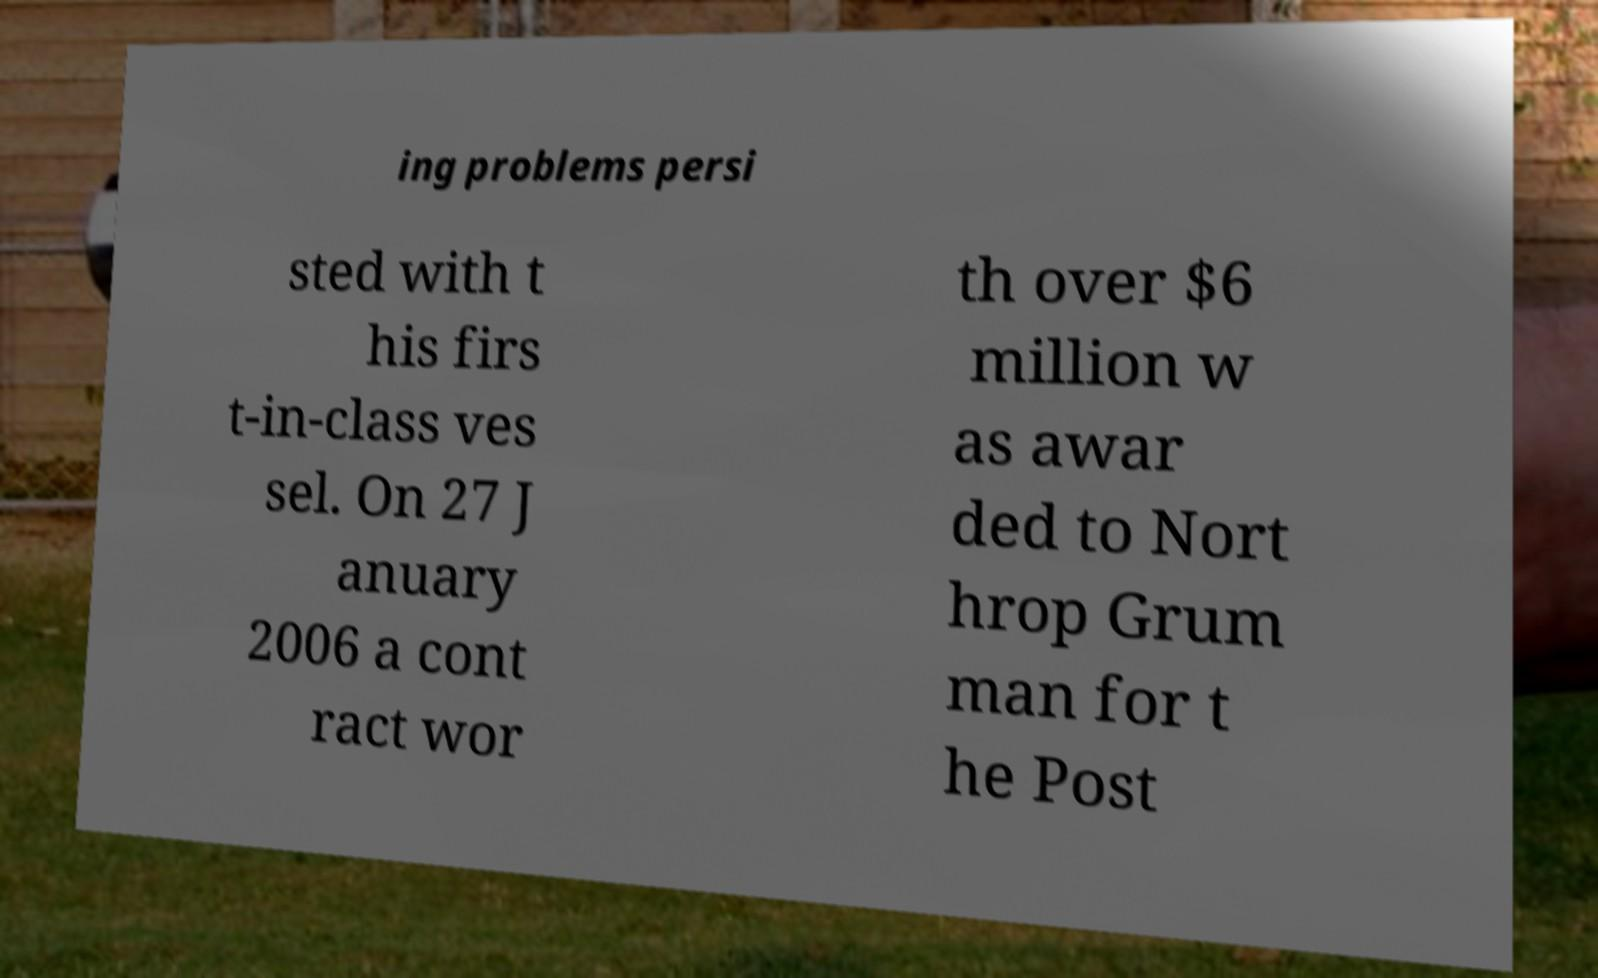Can you read and provide the text displayed in the image?This photo seems to have some interesting text. Can you extract and type it out for me? ing problems persi sted with t his firs t-in-class ves sel. On 27 J anuary 2006 a cont ract wor th over $6 million w as awar ded to Nort hrop Grum man for t he Post 